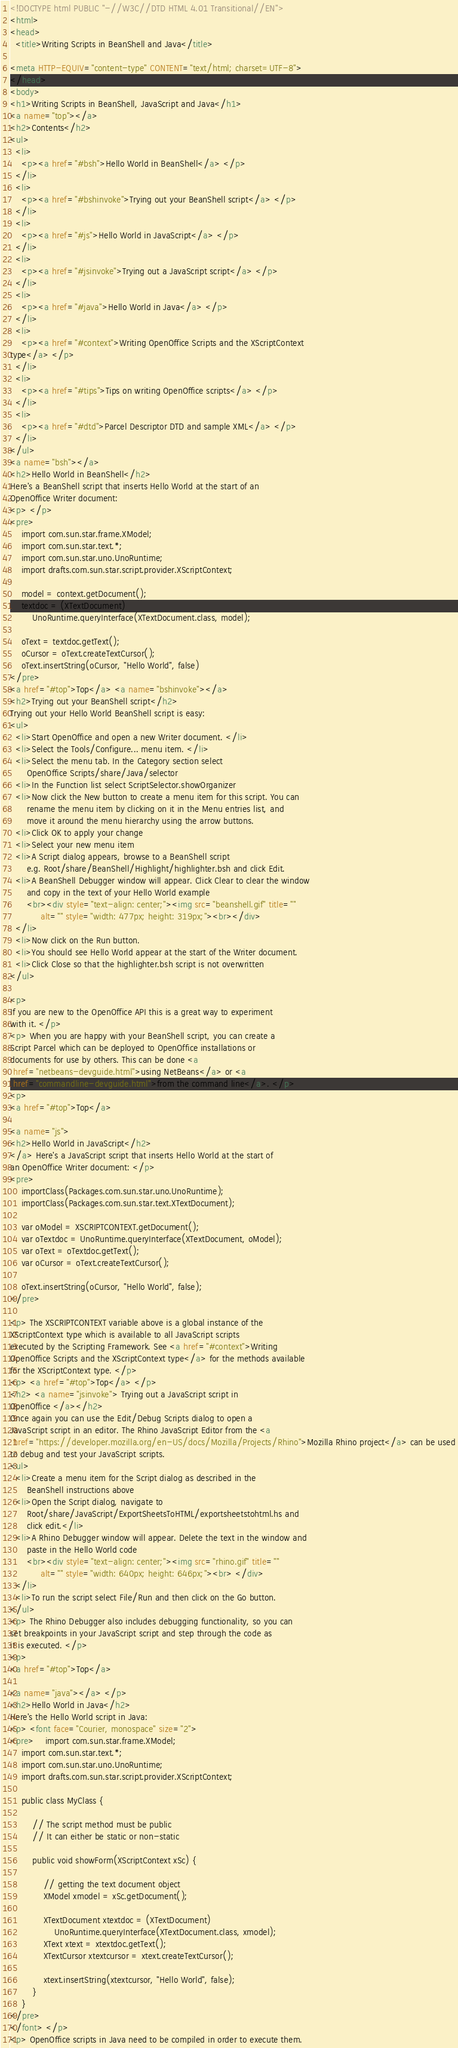<code> <loc_0><loc_0><loc_500><loc_500><_HTML_><!DOCTYPE html PUBLIC "-//W3C//DTD HTML 4.01 Transitional//EN">
<html>
<head>
  <title>Writing Scripts in BeanShell and Java</title>

<meta HTTP-EQUIV="content-type" CONTENT="text/html; charset=UTF-8">
</head>
<body>
<h1>Writing Scripts in BeanShell, JavaScript and Java</h1>
<a name="top"></a>
<h2>Contents</h2>
<ul>
  <li>
    <p><a href="#bsh">Hello World in BeanShell</a> </p>
  </li>
  <li>
    <p><a href="#bshinvoke">Trying out your BeanShell script</a> </p>
  </li>
  <li>
    <p><a href="#js">Hello World in JavaScript</a> </p>
  </li>
  <li>
    <p><a href="#jsinvoke">Trying out a JavaScript script</a> </p>
  </li>
  <li>
    <p><a href="#java">Hello World in Java</a> </p>
  </li>
  <li>
    <p><a href="#context">Writing OpenOffice Scripts and the XScriptContext
type</a> </p>
  </li>
  <li>
    <p><a href="#tips">Tips on writing OpenOffice scripts</a> </p>
  </li>
  <li>
    <p><a href="#dtd">Parcel Descriptor DTD and sample XML</a> </p>
  </li>
</ul>
<a name="bsh"></a>
<h2>Hello World in BeanShell</h2>
Here's a BeanShell script that inserts Hello World at the start of an
OpenOffice Writer document:
<p> </p>
<pre>
    import com.sun.star.frame.XModel;
    import com.sun.star.text.*;
    import com.sun.star.uno.UnoRuntime;
    import drafts.com.sun.star.script.provider.XScriptContext;

    model = context.getDocument();
    textdoc = (XTextDocument)
        UnoRuntime.queryInterface(XTextDocument.class, model);

    oText = textdoc.getText();
    oCursor = oText.createTextCursor();
    oText.insertString(oCursor, "Hello World", false)
</pre>
<a href="#top">Top</a> <a name="bshinvoke"></a>
<h2>Trying out your BeanShell script</h2>
Trying out your Hello World BeanShell script is easy:
<ul>
  <li>Start OpenOffice and open a new Writer document. </li>
  <li>Select the Tools/Configure... menu item. </li>
  <li>Select the menu tab. In the Category section select
      OpenOffice Scripts/share/Java/selector
  <li>In the Function list select ScriptSelector.showOrganizer
  <li>Now click the New button to create a menu item for this script. You can
      rename the menu item by clicking on it in the Menu entries list, and
      move it around the menu hierarchy using the arrow buttons.
  <li>Click OK to apply your change
  <li>Select your new menu item
  <li>A Script dialog appears, browse to a BeanShell script
      e.g. Root/share/BeanShell/Highlight/highlighter.bsh and click Edit.
  <li>A BeanShell Debugger window will appear. Click Clear to clear the window
      and copy in the text of your Hello World example
      <br><div style="text-align: center;"><img src="beanshell.gif" title=""
           alt="" style="width: 477px; height: 319px;"><br></div>
  </li>
  <li>Now click on the Run button.
  <li>You should see Hello World appear at the start of the Writer document.
  <li>Click Close so that the highlighter.bsh script is not overwritten
</ul>

<p>
If you are new to the OpenOffice API this is a great way to experiment
with it. </p>
<p> When you are happy with your BeanShell script, you can create a
Script Parcel which can be deployed to OpenOffice installations or
documents for use by others. This can be done <a
 href="netbeans-devguide.html">using NetBeans</a> or <a
 href="commandline-devguide.html">from the command line</a>. </p>
<p>
<a href="#top">Top</a>

<a name="js">
<h2>Hello World in JavaScript</h2>
</a> Here's a JavaScript script that inserts Hello World at the start of
an OpenOffice Writer document: </p>
<pre>
    importClass(Packages.com.sun.star.uno.UnoRuntime);
    importClass(Packages.com.sun.star.text.XTextDocument);

    var oModel = XSCRIPTCONTEXT.getDocument();
    var oTextdoc = UnoRuntime.queryInterface(XTextDocument, oModel);
    var oText = oTextdoc.getText();
    var oCursor = oText.createTextCursor();

    oText.insertString(oCursor, "Hello World", false);
</pre>

<p> The XSCRIPTCONTEXT variable above is a global instance of the
XScriptContext type which is available to all JavaScript scripts
executed by the Scripting Framework. See <a href="#context">Writing
OpenOffice Scripts and the XScriptContext type</a> for the methods available
for the XScriptContext type. </p>
<p> <a href="#top">Top</a> </p>
<h2> <a name="jsinvoke"> Trying out a JavaScript script in
OpenOffice </a></h2>
Once again you can use the Edit/Debug Scripts dialog to open a
JavaScript script in an editor. The Rhino JavaScript Editor from the <a
 href="https://developer.mozilla.org/en-US/docs/Mozilla/Projects/Rhino">Mozilla Rhino project</a> can be used
to debug and test your JavaScript scripts.
<ul>
  <li>Create a menu item for the Script dialog as described in the
      BeanShell instructions above
  <li>Open the Script dialog, navigate to
      Root/share/JavaScript/ExportSheetsToHTML/exportsheetstohtml.hs and
      click edit.</li>
  <li>A Rhino Debugger window will appear. Delete the text in the window and
      paste in the Hello World code
      <br><div style="text-align: center;"><img src="rhino.gif" title=""
           alt="" style="width: 640px; height: 646px;"><br> </div>
  </li>
  <li>To run the script select File/Run and then click on the Go button.
</ul>
<p> The Rhino Debugger also includes debugging functionality, so you can
set breakpoints in your JavaScript script and step through the code as
it is executed. </p>
<p>
<a href="#top">Top</a>

<a name="java"></a> </p>
<h2>Hello World in Java</h2>
Here's the Hello World script in Java:
<p> <font face="Courier, monospace" size="2">
<pre>    import com.sun.star.frame.XModel;
    import com.sun.star.text.*;
    import com.sun.star.uno.UnoRuntime;
    import drafts.com.sun.star.script.provider.XScriptContext;

    public class MyClass {

        // The script method must be public
        // It can either be static or non-static

        public void showForm(XScriptContext xSc) {

            // getting the text document object
            XModel xmodel = xSc.getDocument();

            XTextDocument xtextdoc = (XTextDocument)
                UnoRuntime.queryInterface(XTextDocument.class, xmodel);
            XText xtext = xtextdoc.getText();
            XTextCursor xtextcursor = xtext.createTextCursor();

            xtext.insertString(xtextcursor, "Hello World", false);
        }
    }
</pre>
</font> </p>
<p> OpenOffice scripts in Java need to be compiled in order to execute them.</code> 